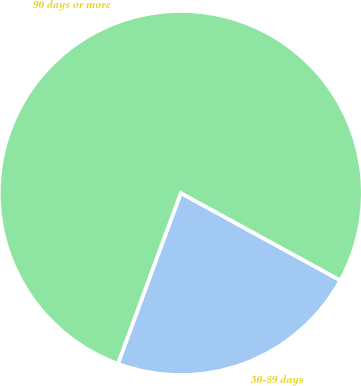Convert chart. <chart><loc_0><loc_0><loc_500><loc_500><pie_chart><fcel>30-89 days<fcel>90 days or more<nl><fcel>22.65%<fcel>77.35%<nl></chart> 